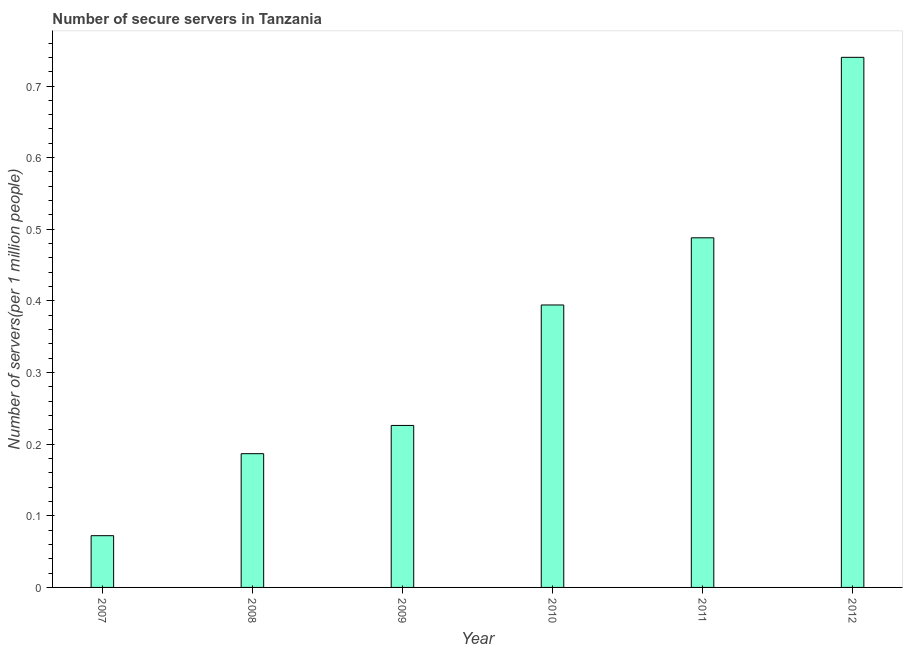Does the graph contain grids?
Your answer should be compact. No. What is the title of the graph?
Your response must be concise. Number of secure servers in Tanzania. What is the label or title of the X-axis?
Provide a succinct answer. Year. What is the label or title of the Y-axis?
Offer a terse response. Number of servers(per 1 million people). What is the number of secure internet servers in 2009?
Your answer should be compact. 0.23. Across all years, what is the maximum number of secure internet servers?
Keep it short and to the point. 0.74. Across all years, what is the minimum number of secure internet servers?
Provide a succinct answer. 0.07. In which year was the number of secure internet servers maximum?
Provide a succinct answer. 2012. What is the sum of the number of secure internet servers?
Provide a succinct answer. 2.11. What is the difference between the number of secure internet servers in 2010 and 2012?
Offer a terse response. -0.35. What is the average number of secure internet servers per year?
Make the answer very short. 0.35. What is the median number of secure internet servers?
Your answer should be very brief. 0.31. What is the ratio of the number of secure internet servers in 2010 to that in 2012?
Provide a succinct answer. 0.53. Is the difference between the number of secure internet servers in 2009 and 2011 greater than the difference between any two years?
Provide a succinct answer. No. What is the difference between the highest and the second highest number of secure internet servers?
Offer a very short reply. 0.25. Is the sum of the number of secure internet servers in 2007 and 2012 greater than the maximum number of secure internet servers across all years?
Give a very brief answer. Yes. What is the difference between the highest and the lowest number of secure internet servers?
Offer a terse response. 0.67. Are all the bars in the graph horizontal?
Make the answer very short. No. Are the values on the major ticks of Y-axis written in scientific E-notation?
Your answer should be very brief. No. What is the Number of servers(per 1 million people) of 2007?
Provide a succinct answer. 0.07. What is the Number of servers(per 1 million people) in 2008?
Offer a very short reply. 0.19. What is the Number of servers(per 1 million people) of 2009?
Make the answer very short. 0.23. What is the Number of servers(per 1 million people) of 2010?
Give a very brief answer. 0.39. What is the Number of servers(per 1 million people) in 2011?
Give a very brief answer. 0.49. What is the Number of servers(per 1 million people) in 2012?
Ensure brevity in your answer.  0.74. What is the difference between the Number of servers(per 1 million people) in 2007 and 2008?
Your answer should be compact. -0.11. What is the difference between the Number of servers(per 1 million people) in 2007 and 2009?
Offer a terse response. -0.15. What is the difference between the Number of servers(per 1 million people) in 2007 and 2010?
Make the answer very short. -0.32. What is the difference between the Number of servers(per 1 million people) in 2007 and 2011?
Offer a terse response. -0.42. What is the difference between the Number of servers(per 1 million people) in 2007 and 2012?
Offer a terse response. -0.67. What is the difference between the Number of servers(per 1 million people) in 2008 and 2009?
Provide a short and direct response. -0.04. What is the difference between the Number of servers(per 1 million people) in 2008 and 2010?
Ensure brevity in your answer.  -0.21. What is the difference between the Number of servers(per 1 million people) in 2008 and 2011?
Offer a terse response. -0.3. What is the difference between the Number of servers(per 1 million people) in 2008 and 2012?
Your answer should be very brief. -0.55. What is the difference between the Number of servers(per 1 million people) in 2009 and 2010?
Give a very brief answer. -0.17. What is the difference between the Number of servers(per 1 million people) in 2009 and 2011?
Your answer should be compact. -0.26. What is the difference between the Number of servers(per 1 million people) in 2009 and 2012?
Make the answer very short. -0.51. What is the difference between the Number of servers(per 1 million people) in 2010 and 2011?
Offer a very short reply. -0.09. What is the difference between the Number of servers(per 1 million people) in 2010 and 2012?
Your response must be concise. -0.35. What is the difference between the Number of servers(per 1 million people) in 2011 and 2012?
Your response must be concise. -0.25. What is the ratio of the Number of servers(per 1 million people) in 2007 to that in 2008?
Your answer should be very brief. 0.39. What is the ratio of the Number of servers(per 1 million people) in 2007 to that in 2009?
Provide a succinct answer. 0.32. What is the ratio of the Number of servers(per 1 million people) in 2007 to that in 2010?
Keep it short and to the point. 0.18. What is the ratio of the Number of servers(per 1 million people) in 2007 to that in 2011?
Your answer should be very brief. 0.15. What is the ratio of the Number of servers(per 1 million people) in 2007 to that in 2012?
Your answer should be very brief. 0.1. What is the ratio of the Number of servers(per 1 million people) in 2008 to that in 2009?
Your response must be concise. 0.83. What is the ratio of the Number of servers(per 1 million people) in 2008 to that in 2010?
Offer a terse response. 0.47. What is the ratio of the Number of servers(per 1 million people) in 2008 to that in 2011?
Give a very brief answer. 0.38. What is the ratio of the Number of servers(per 1 million people) in 2008 to that in 2012?
Ensure brevity in your answer.  0.25. What is the ratio of the Number of servers(per 1 million people) in 2009 to that in 2010?
Keep it short and to the point. 0.57. What is the ratio of the Number of servers(per 1 million people) in 2009 to that in 2011?
Provide a short and direct response. 0.46. What is the ratio of the Number of servers(per 1 million people) in 2009 to that in 2012?
Offer a terse response. 0.31. What is the ratio of the Number of servers(per 1 million people) in 2010 to that in 2011?
Give a very brief answer. 0.81. What is the ratio of the Number of servers(per 1 million people) in 2010 to that in 2012?
Keep it short and to the point. 0.53. What is the ratio of the Number of servers(per 1 million people) in 2011 to that in 2012?
Your answer should be compact. 0.66. 